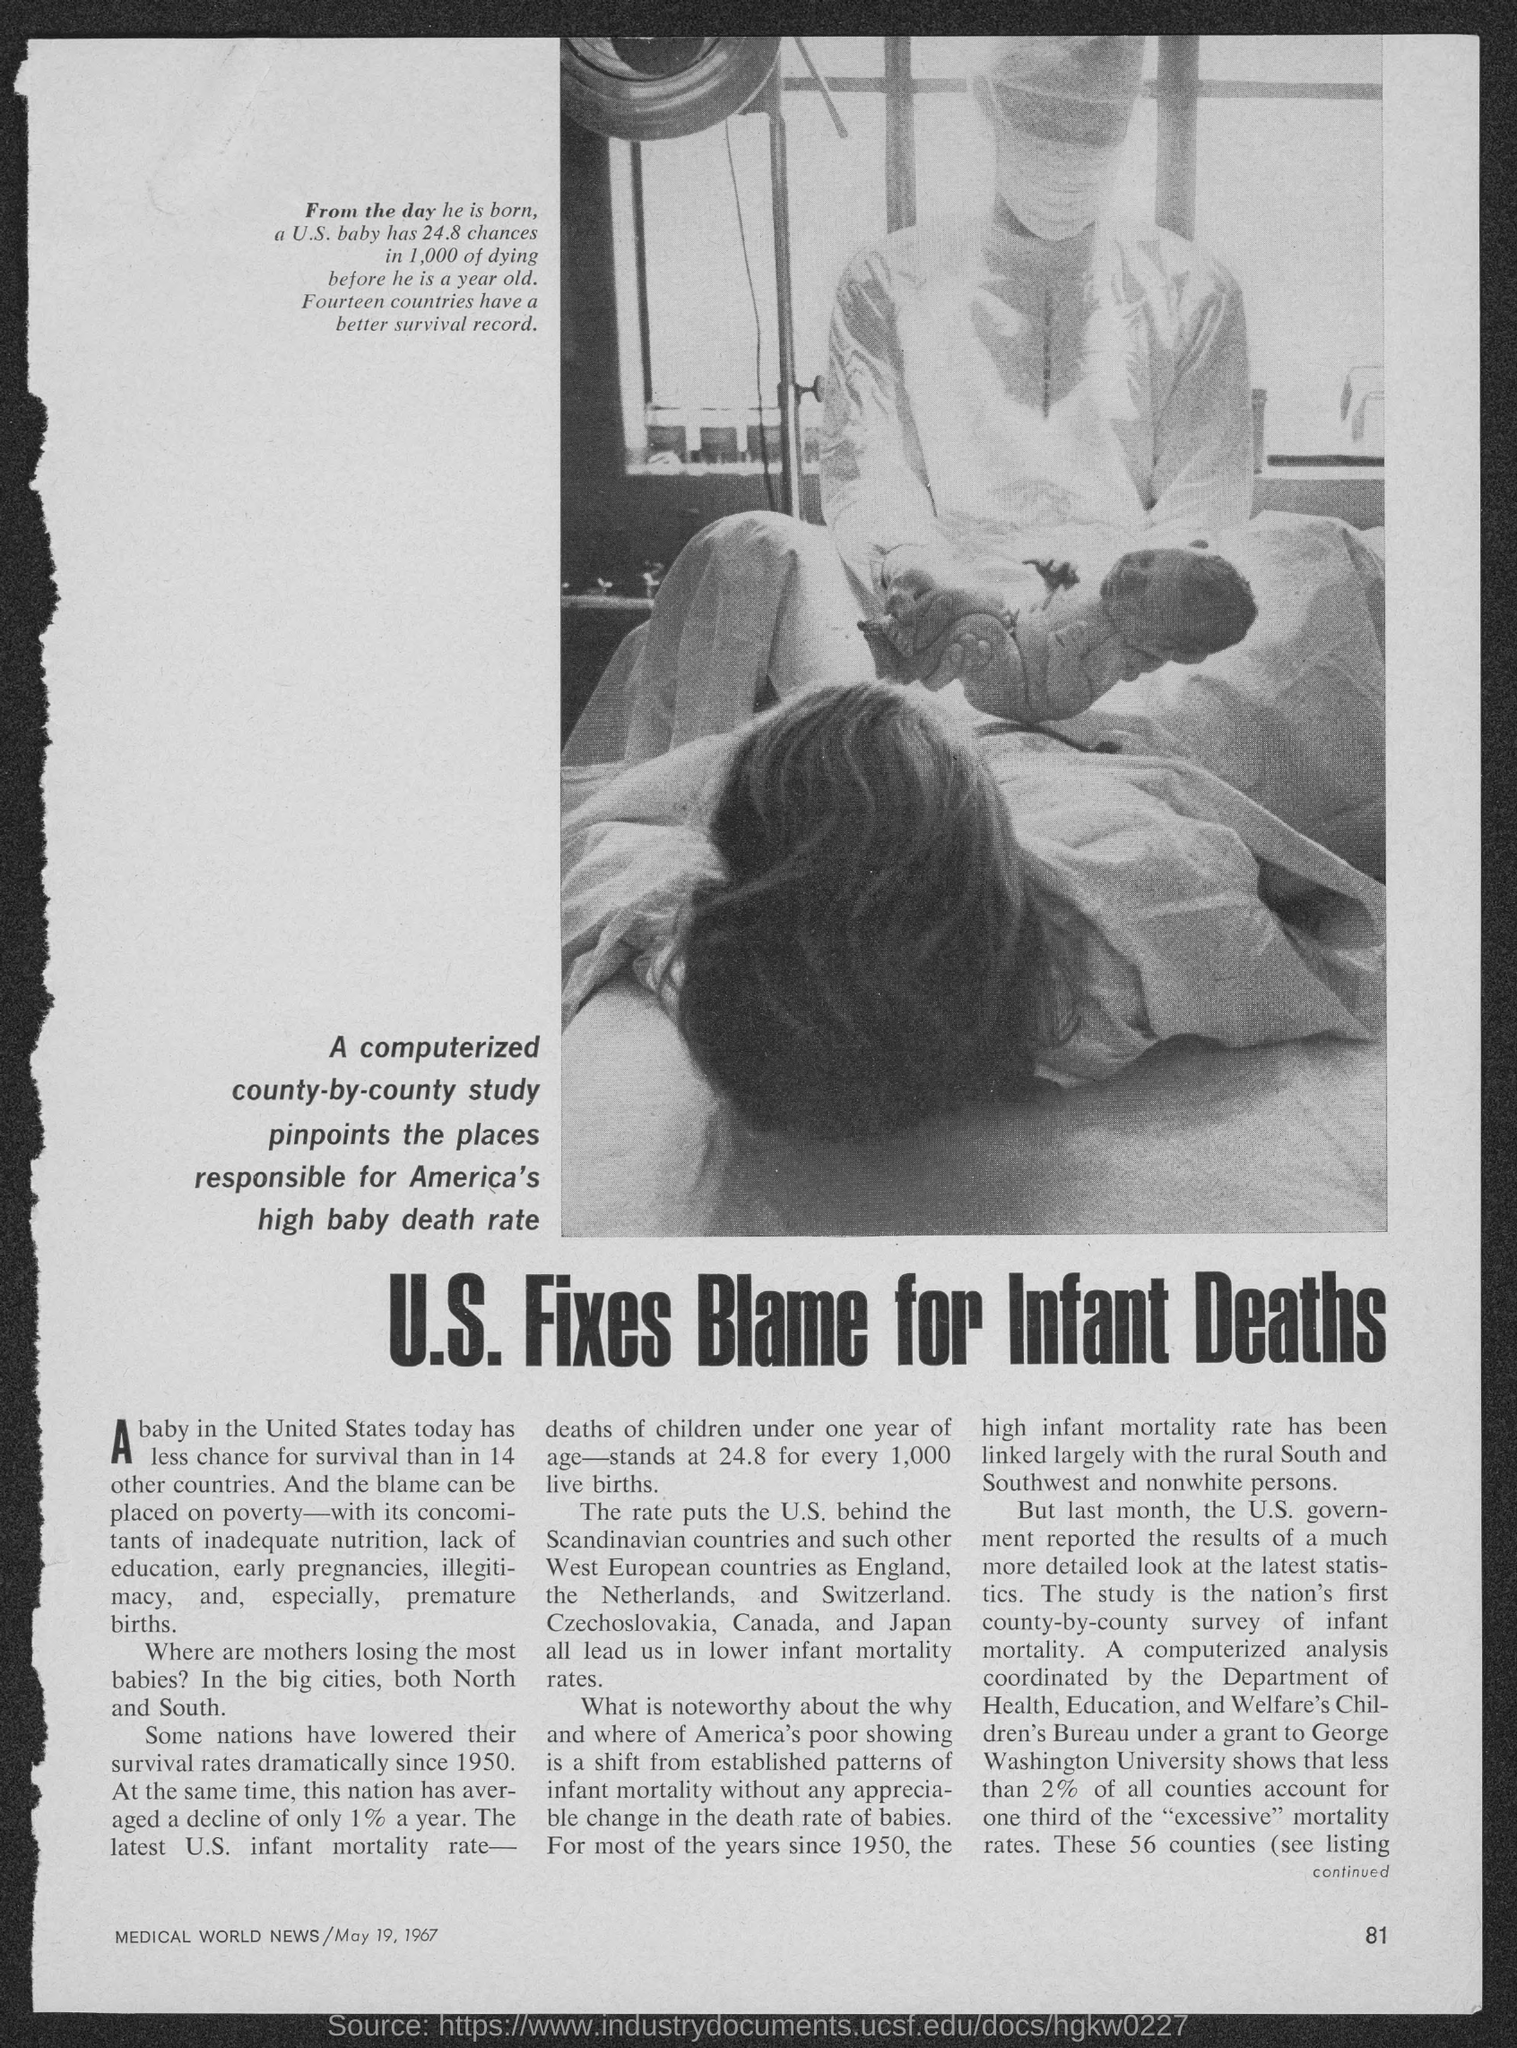What is the page no mentioned in the magazine?
Make the answer very short. 81. What is the name of the magazine given here?
Make the answer very short. MEDICAL WORLD NEWS. What is the date mentioned in the magazine?
Your answer should be compact. May 19, 1967. What is the headline of the news given?
Your answer should be compact. U.S. Fixes Blame for Infant Deaths. 